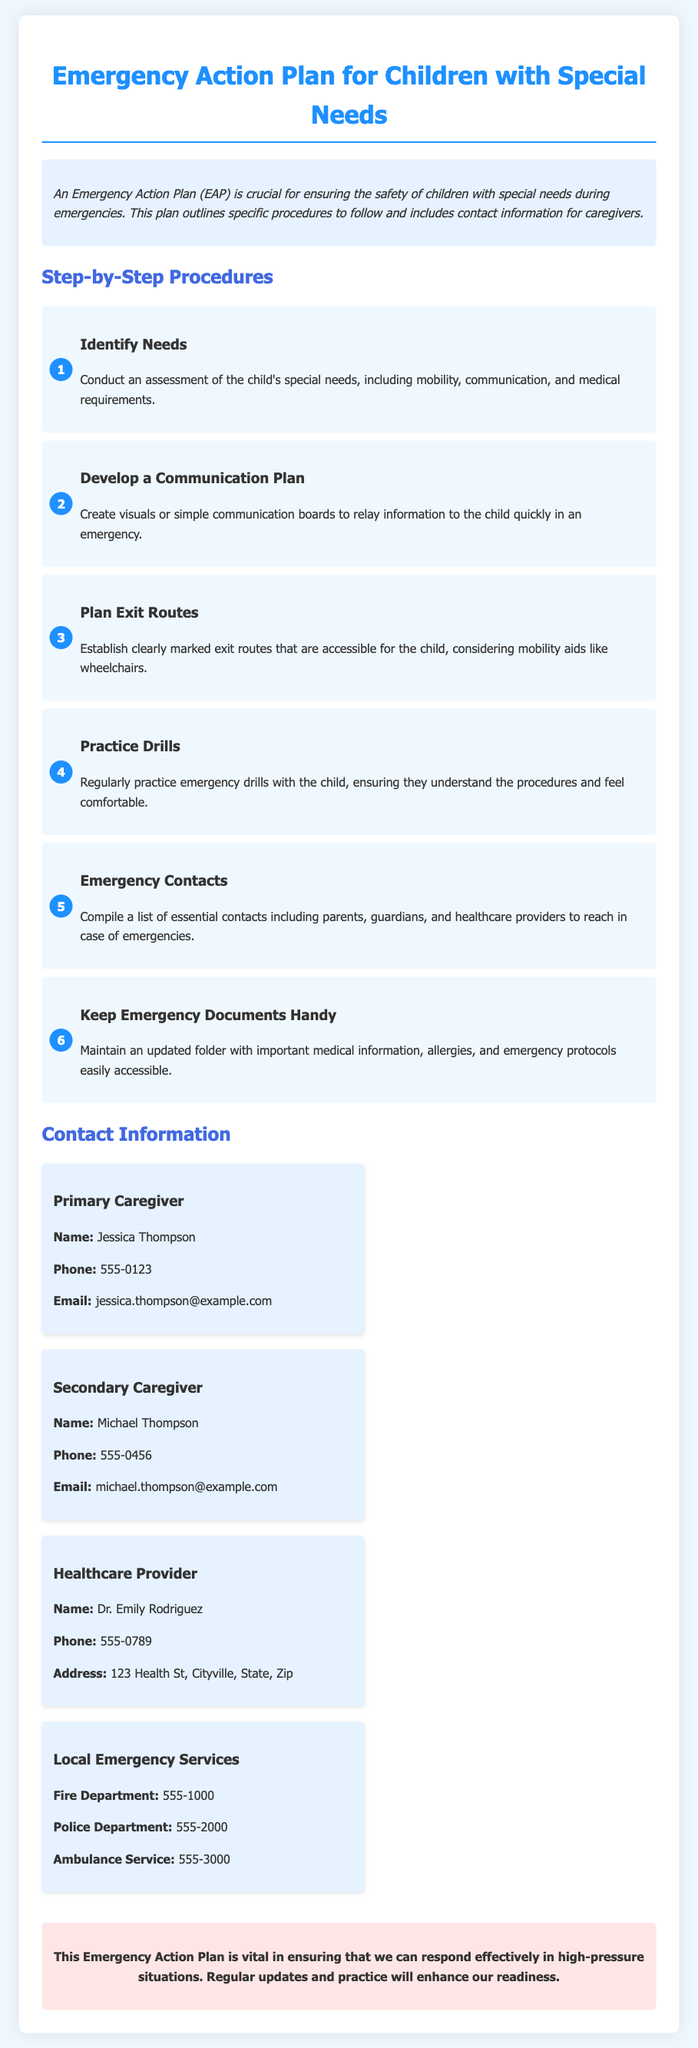What is the title of the document? The title is clearly stated at the beginning of the document.
Answer: Emergency Action Plan for Children with Special Needs Who is the primary caregiver? The name of the primary caregiver is mentioned in the contact section of the document.
Answer: Jessica Thompson What step involves establishing exit routes? The document outlines multiple steps; this particular information can be found in the step headings.
Answer: Plan Exit Routes How many emergency contact numbers are provided in the document? The document includes several contact details listed under various categories.
Answer: Four What is the phone number for the healthcare provider? The phone number is part of the healthcare provider's contact information section.
Answer: 555-0789 What type of plan is outlined in the document? The primary focus of the document can be inferred from the title and the introductory paragraph.
Answer: Emergency Action Plan What is the final note's emphasis? The final note summarizes the importance of a specific aspect discussed throughout the document.
Answer: Regular updates and practice 